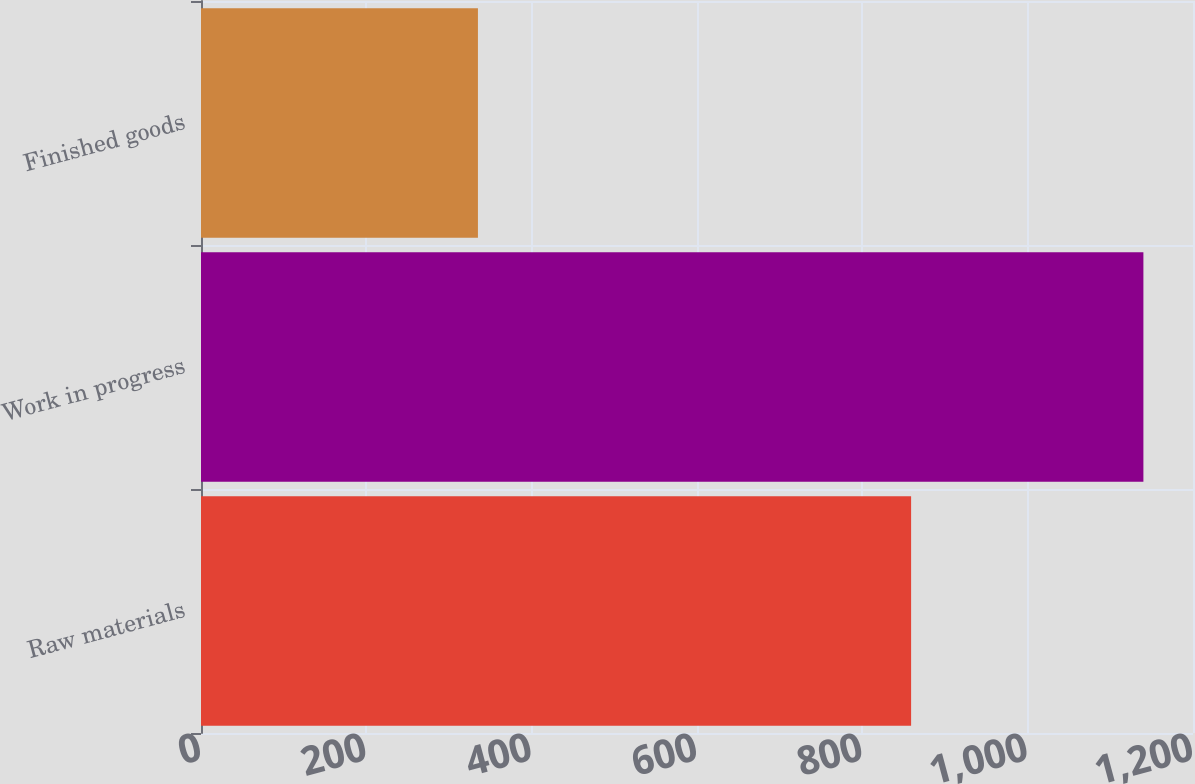Convert chart to OTSL. <chart><loc_0><loc_0><loc_500><loc_500><bar_chart><fcel>Raw materials<fcel>Work in progress<fcel>Finished goods<nl><fcel>859<fcel>1140<fcel>335<nl></chart> 